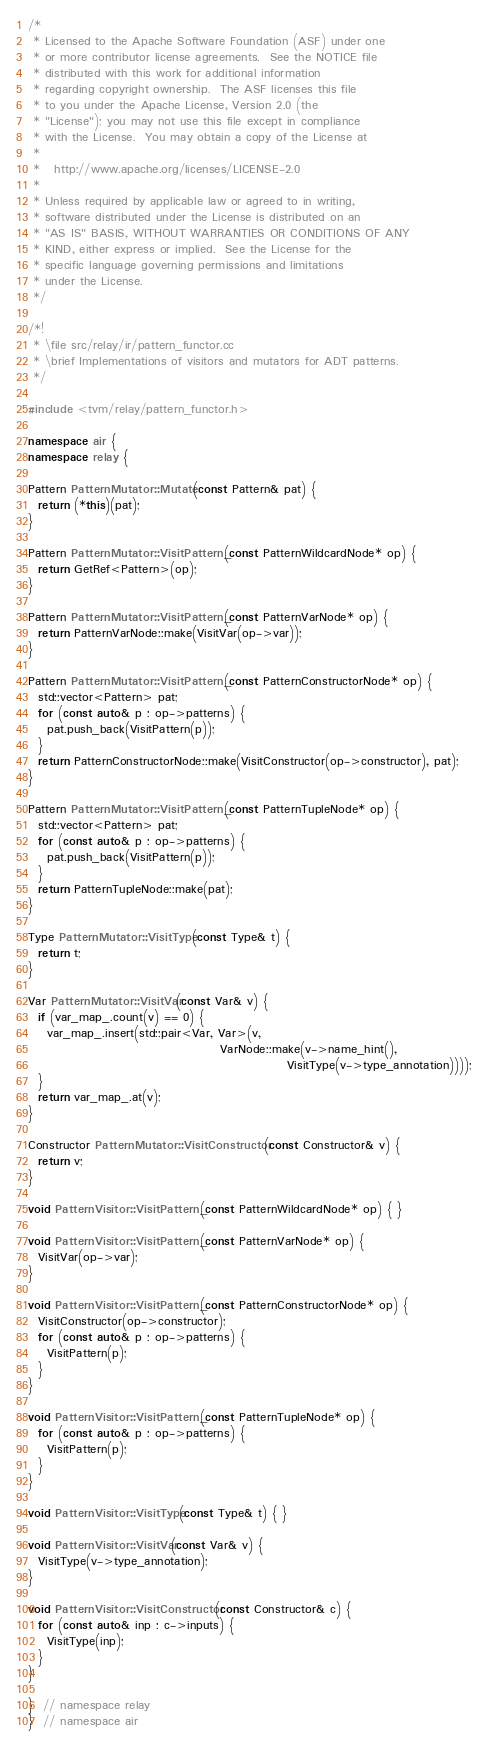<code> <loc_0><loc_0><loc_500><loc_500><_C++_>/*
 * Licensed to the Apache Software Foundation (ASF) under one
 * or more contributor license agreements.  See the NOTICE file
 * distributed with this work for additional information
 * regarding copyright ownership.  The ASF licenses this file
 * to you under the Apache License, Version 2.0 (the
 * "License"); you may not use this file except in compliance
 * with the License.  You may obtain a copy of the License at
 *
 *   http://www.apache.org/licenses/LICENSE-2.0
 *
 * Unless required by applicable law or agreed to in writing,
 * software distributed under the License is distributed on an
 * "AS IS" BASIS, WITHOUT WARRANTIES OR CONDITIONS OF ANY
 * KIND, either express or implied.  See the License for the
 * specific language governing permissions and limitations
 * under the License.
 */

/*!
 * \file src/relay/ir/pattern_functor.cc
 * \brief Implementations of visitors and mutators for ADT patterns.
 */

#include <tvm/relay/pattern_functor.h>

namespace air {
namespace relay {

Pattern PatternMutator::Mutate(const Pattern& pat) {
  return (*this)(pat);
}

Pattern PatternMutator::VisitPattern_(const PatternWildcardNode* op) {
  return GetRef<Pattern>(op);
}

Pattern PatternMutator::VisitPattern_(const PatternVarNode* op) {
  return PatternVarNode::make(VisitVar(op->var));
}

Pattern PatternMutator::VisitPattern_(const PatternConstructorNode* op) {
  std::vector<Pattern> pat;
  for (const auto& p : op->patterns) {
    pat.push_back(VisitPattern(p));
  }
  return PatternConstructorNode::make(VisitConstructor(op->constructor), pat);
}

Pattern PatternMutator::VisitPattern_(const PatternTupleNode* op) {
  std::vector<Pattern> pat;
  for (const auto& p : op->patterns) {
    pat.push_back(VisitPattern(p));
  }
  return PatternTupleNode::make(pat);
}

Type PatternMutator::VisitType(const Type& t) {
  return t;
}

Var PatternMutator::VisitVar(const Var& v) {
  if (var_map_.count(v) == 0) {
    var_map_.insert(std::pair<Var, Var>(v,
                                        VarNode::make(v->name_hint(),
                                                      VisitType(v->type_annotation))));
  }
  return var_map_.at(v);
}

Constructor PatternMutator::VisitConstructor(const Constructor& v) {
  return v;
}

void PatternVisitor::VisitPattern_(const PatternWildcardNode* op) { }

void PatternVisitor::VisitPattern_(const PatternVarNode* op) {
  VisitVar(op->var);
}

void PatternVisitor::VisitPattern_(const PatternConstructorNode* op) {
  VisitConstructor(op->constructor);
  for (const auto& p : op->patterns) {
    VisitPattern(p);
  }
}

void PatternVisitor::VisitPattern_(const PatternTupleNode* op) {
  for (const auto& p : op->patterns) {
    VisitPattern(p);
  }
}

void PatternVisitor::VisitType(const Type& t) { }

void PatternVisitor::VisitVar(const Var& v) {
  VisitType(v->type_annotation);
}

void PatternVisitor::VisitConstructor(const Constructor& c) {
  for (const auto& inp : c->inputs) {
    VisitType(inp);
  }
}

}  // namespace relay
}  // namespace air
</code> 